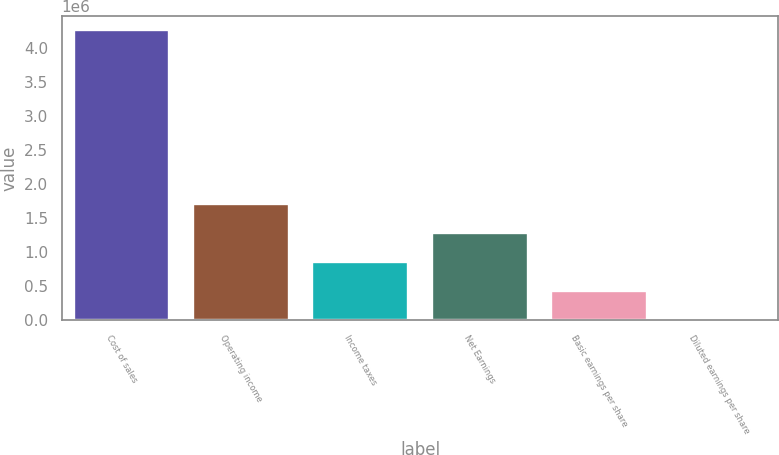Convert chart. <chart><loc_0><loc_0><loc_500><loc_500><bar_chart><fcel>Cost of sales<fcel>Operating income<fcel>Income taxes<fcel>Net Earnings<fcel>Basic earnings per share<fcel>Diluted earnings per share<nl><fcel>4.25953e+06<fcel>1.70382e+06<fcel>851911<fcel>1.27786e+06<fcel>425958<fcel>5.46<nl></chart> 